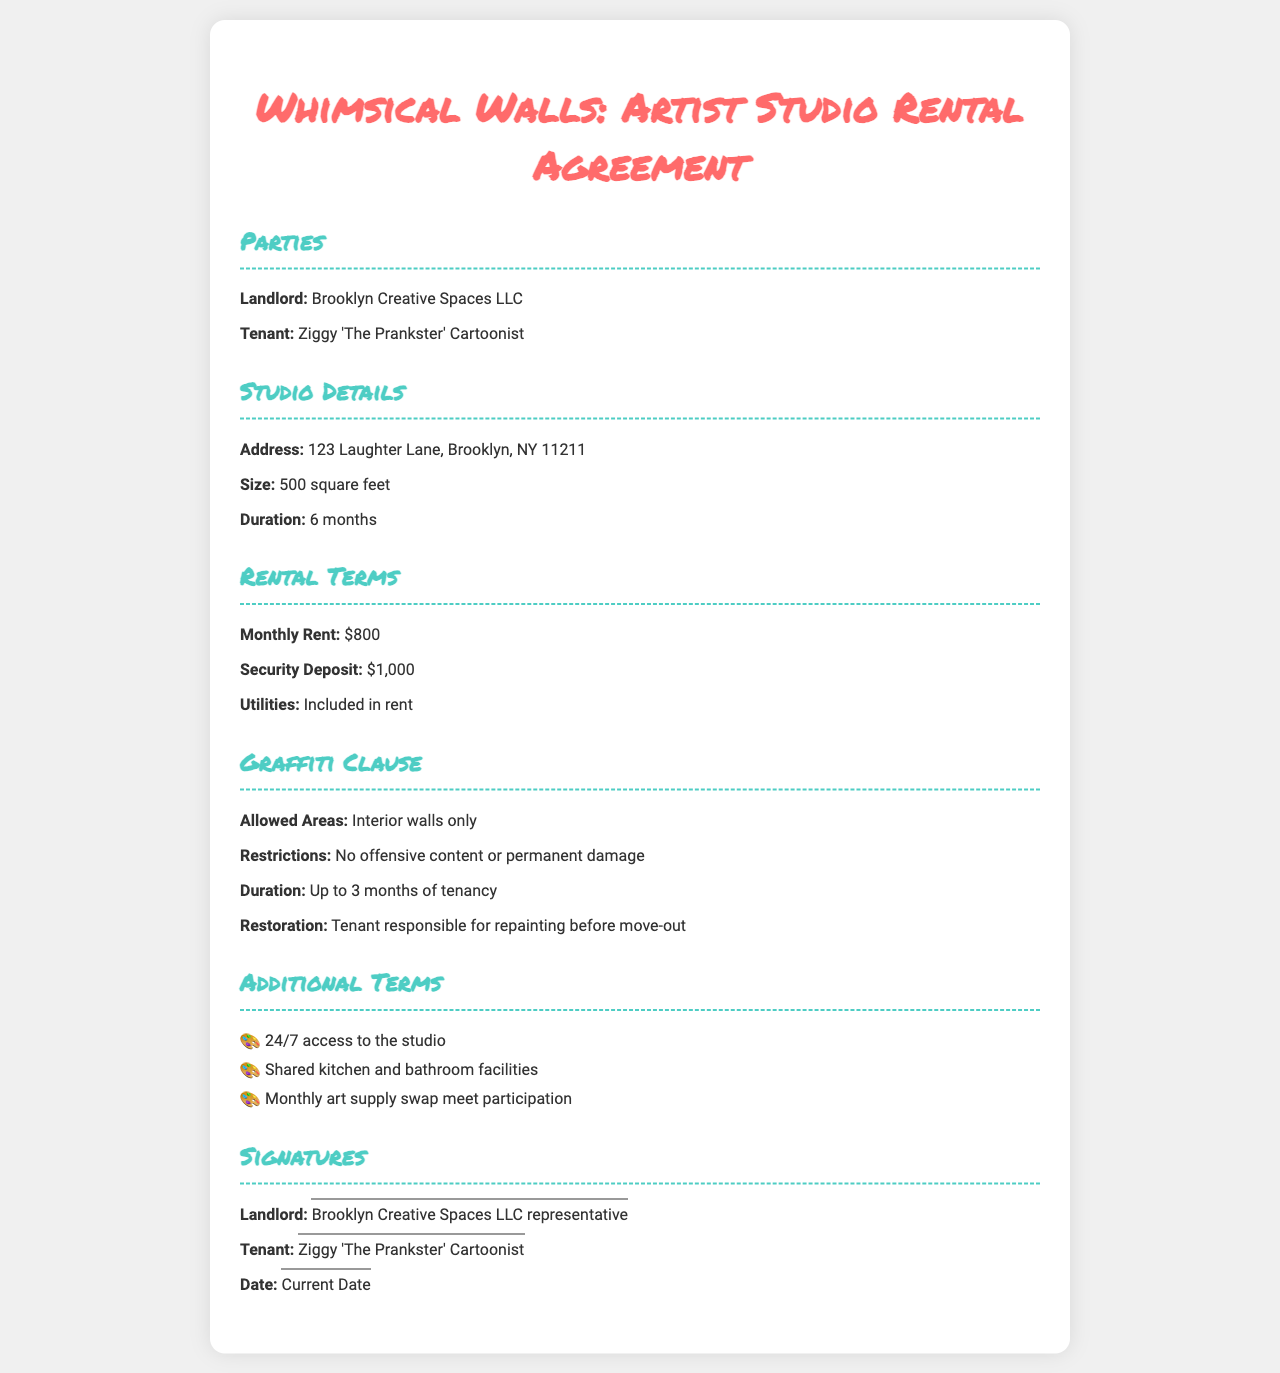What is the name of the landlord? The landlord is identified as Brooklyn Creative Spaces LLC in the document.
Answer: Brooklyn Creative Spaces LLC Who is the tenant? The tenant's name is mentioned in the document as Ziggy 'The Prankster' Cartoonist.
Answer: Ziggy 'The Prankster' Cartoonist What is the monthly rent for the studio? The document specifies the monthly rent is $800.
Answer: $800 How long is the studio rental agreement? The rental duration mentioned in the document is 6 months.
Answer: 6 months What are the allowed areas for graffiti? The document states that graffiti is allowed on the interior walls only.
Answer: Interior walls only What is the tenant responsible for before move-out? The document highlights that the tenant is responsible for repainting.
Answer: Repainting What is the security deposit amount? The document lists the security deposit as $1,000.
Answer: $1,000 What is the maximum duration for graffiti allowed? The document indicates that graffiti is permitted for up to 3 months of tenancy.
Answer: Up to 3 months What additional facility is shared in the studio? The document includes shared kitchen and bathroom facilities as part of the additional terms.
Answer: Shared kitchen and bathroom facilities 